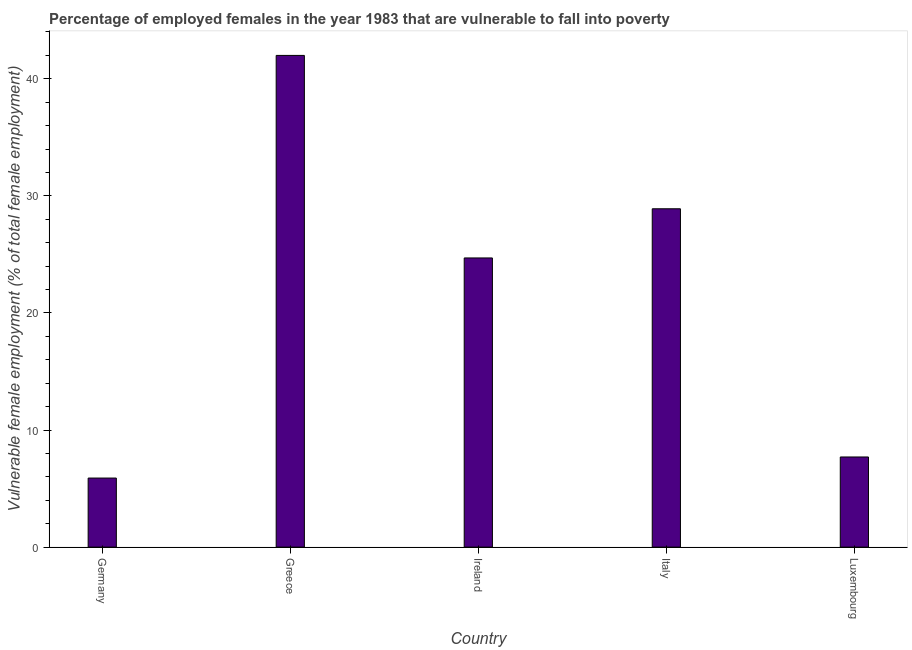Does the graph contain any zero values?
Offer a terse response. No. What is the title of the graph?
Ensure brevity in your answer.  Percentage of employed females in the year 1983 that are vulnerable to fall into poverty. What is the label or title of the X-axis?
Offer a very short reply. Country. What is the label or title of the Y-axis?
Provide a succinct answer. Vulnerable female employment (% of total female employment). What is the percentage of employed females who are vulnerable to fall into poverty in Luxembourg?
Offer a terse response. 7.7. Across all countries, what is the minimum percentage of employed females who are vulnerable to fall into poverty?
Give a very brief answer. 5.9. In which country was the percentage of employed females who are vulnerable to fall into poverty minimum?
Provide a succinct answer. Germany. What is the sum of the percentage of employed females who are vulnerable to fall into poverty?
Your answer should be very brief. 109.2. What is the average percentage of employed females who are vulnerable to fall into poverty per country?
Offer a terse response. 21.84. What is the median percentage of employed females who are vulnerable to fall into poverty?
Your answer should be very brief. 24.7. In how many countries, is the percentage of employed females who are vulnerable to fall into poverty greater than 24 %?
Make the answer very short. 3. What is the ratio of the percentage of employed females who are vulnerable to fall into poverty in Germany to that in Greece?
Your response must be concise. 0.14. What is the difference between the highest and the second highest percentage of employed females who are vulnerable to fall into poverty?
Your answer should be compact. 13.1. What is the difference between the highest and the lowest percentage of employed females who are vulnerable to fall into poverty?
Provide a succinct answer. 36.1. How many bars are there?
Make the answer very short. 5. Are all the bars in the graph horizontal?
Your answer should be compact. No. What is the difference between two consecutive major ticks on the Y-axis?
Offer a terse response. 10. Are the values on the major ticks of Y-axis written in scientific E-notation?
Provide a short and direct response. No. What is the Vulnerable female employment (% of total female employment) of Germany?
Give a very brief answer. 5.9. What is the Vulnerable female employment (% of total female employment) in Ireland?
Your answer should be compact. 24.7. What is the Vulnerable female employment (% of total female employment) of Italy?
Give a very brief answer. 28.9. What is the Vulnerable female employment (% of total female employment) of Luxembourg?
Your response must be concise. 7.7. What is the difference between the Vulnerable female employment (% of total female employment) in Germany and Greece?
Offer a very short reply. -36.1. What is the difference between the Vulnerable female employment (% of total female employment) in Germany and Ireland?
Your answer should be very brief. -18.8. What is the difference between the Vulnerable female employment (% of total female employment) in Germany and Italy?
Offer a terse response. -23. What is the difference between the Vulnerable female employment (% of total female employment) in Germany and Luxembourg?
Provide a short and direct response. -1.8. What is the difference between the Vulnerable female employment (% of total female employment) in Greece and Ireland?
Your answer should be very brief. 17.3. What is the difference between the Vulnerable female employment (% of total female employment) in Greece and Italy?
Offer a very short reply. 13.1. What is the difference between the Vulnerable female employment (% of total female employment) in Greece and Luxembourg?
Your response must be concise. 34.3. What is the difference between the Vulnerable female employment (% of total female employment) in Italy and Luxembourg?
Keep it short and to the point. 21.2. What is the ratio of the Vulnerable female employment (% of total female employment) in Germany to that in Greece?
Provide a succinct answer. 0.14. What is the ratio of the Vulnerable female employment (% of total female employment) in Germany to that in Ireland?
Keep it short and to the point. 0.24. What is the ratio of the Vulnerable female employment (% of total female employment) in Germany to that in Italy?
Provide a succinct answer. 0.2. What is the ratio of the Vulnerable female employment (% of total female employment) in Germany to that in Luxembourg?
Your answer should be compact. 0.77. What is the ratio of the Vulnerable female employment (% of total female employment) in Greece to that in Ireland?
Provide a short and direct response. 1.7. What is the ratio of the Vulnerable female employment (% of total female employment) in Greece to that in Italy?
Your answer should be very brief. 1.45. What is the ratio of the Vulnerable female employment (% of total female employment) in Greece to that in Luxembourg?
Give a very brief answer. 5.46. What is the ratio of the Vulnerable female employment (% of total female employment) in Ireland to that in Italy?
Offer a very short reply. 0.85. What is the ratio of the Vulnerable female employment (% of total female employment) in Ireland to that in Luxembourg?
Ensure brevity in your answer.  3.21. What is the ratio of the Vulnerable female employment (% of total female employment) in Italy to that in Luxembourg?
Provide a succinct answer. 3.75. 